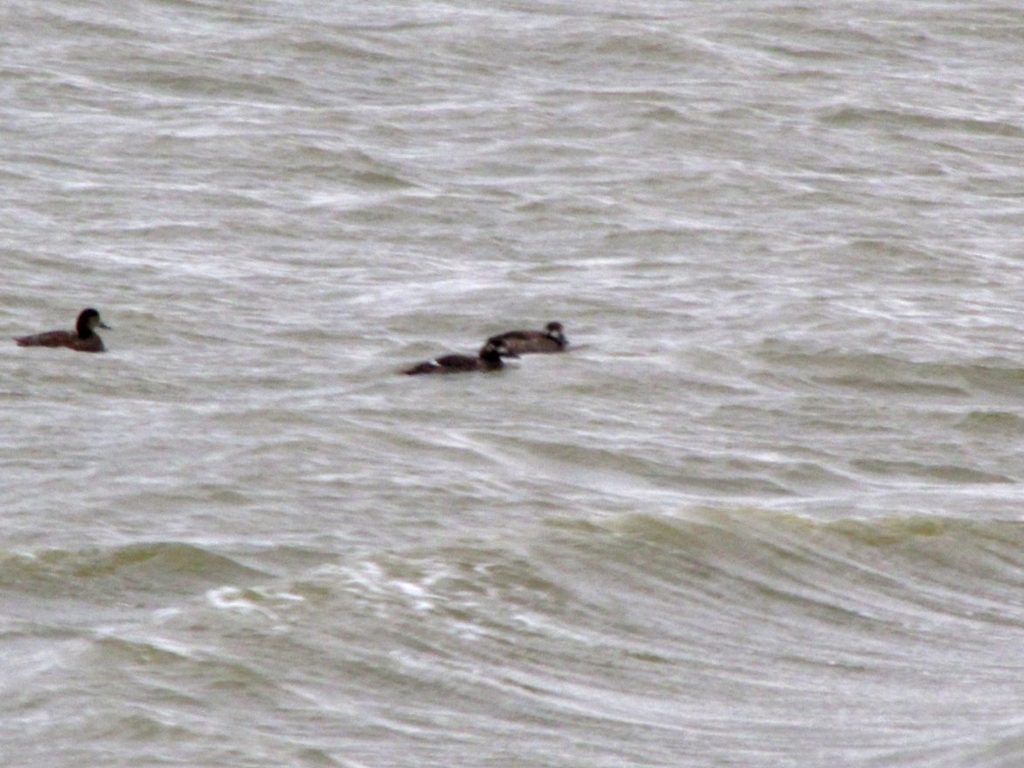How does the water condition seem to affect the ducks in this image? The ducks appear to be well-adapted to the choppy water conditions, maintaining buoyancy and navigating with ease. Such water conditions might indicate a windy climate or the presence of currents, both of which ducks can typically manage due to their aquatic nature. 